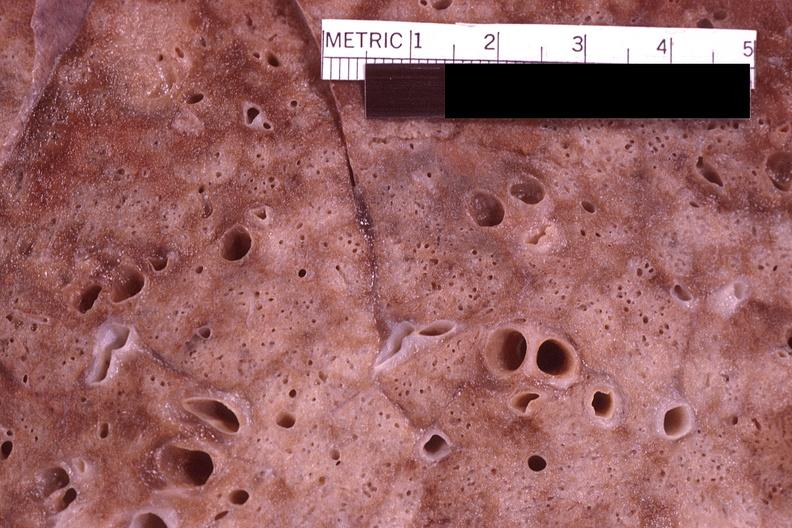does this image show lung, pneumocystis pneumonia?
Answer the question using a single word or phrase. Yes 